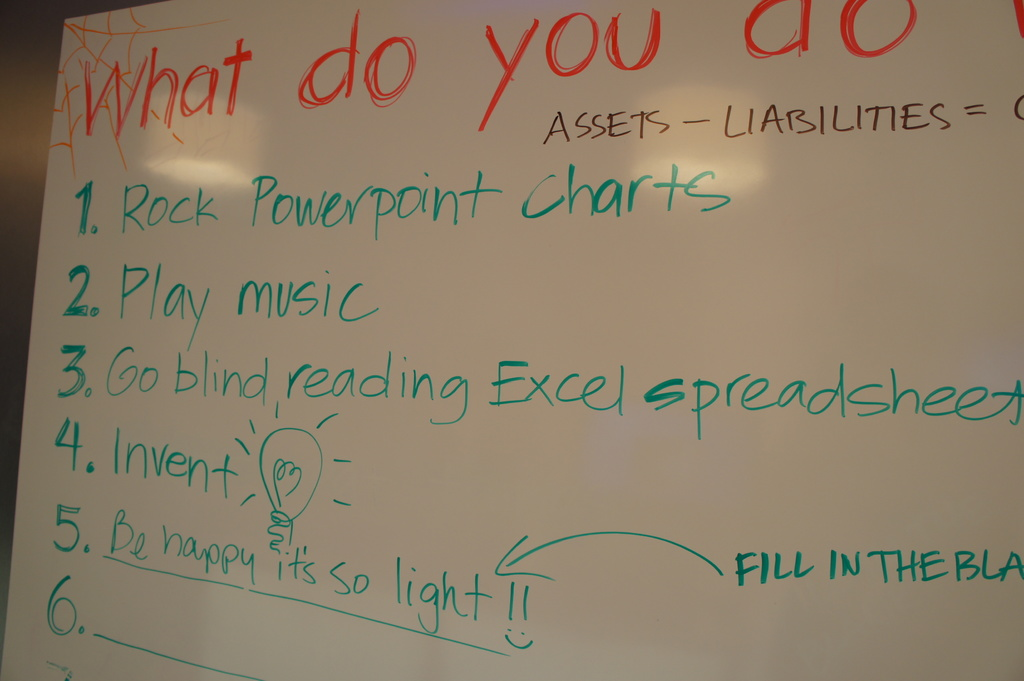What might be a reason for including 'Play music' on the whiteboard as a strategy? Including 'Play music' as a strategy on the whiteboard suggests using music as a way to enhance creative thinking and productivity. Music can help to create a relaxed and positive atmosphere, making it easier to think innovatively and freely as the team tackles the problem of managing assets, liabilities, and equity. 